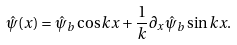Convert formula to latex. <formula><loc_0><loc_0><loc_500><loc_500>\hat { \psi } ( x ) = \hat { \psi } _ { b } \cos k x + \frac { 1 } { k } \partial _ { x } \hat { \psi } _ { b } \sin k x .</formula> 